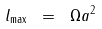Convert formula to latex. <formula><loc_0><loc_0><loc_500><loc_500>l _ { \max } \ = \ \Omega a ^ { 2 }</formula> 